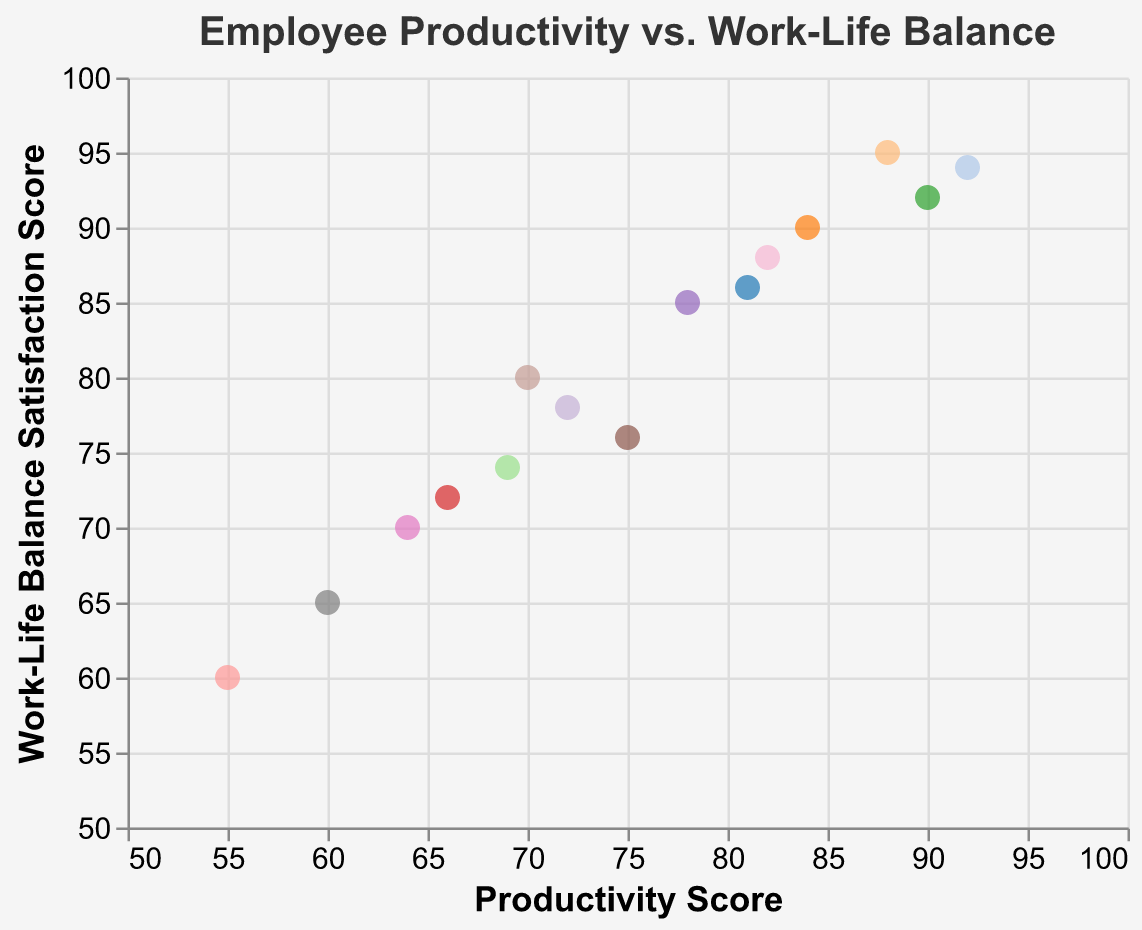What's the title of the scatter plot? The title is usually found at the top of the chart and indicates what the chart is about. By inspecting the plot, we can see the title text clearly.
Answer: Employee Productivity vs. Work-Life Balance What is the range of the Productivity Score on the x-axis? To determine the range of the x-axis, we inspect the minimum and maximum values shown on the axis. The scores range from 50 to 100.
Answer: 50 to 100 Which employee has both the highest Productivity Score and Work-Life Balance Satisfaction Score? To find this information, look for the highest points on both the x-axis and y-axis and check the tooltip details or the data plot.
Answer: Daniel Anderson How many employees have a Productivity Score greater than 80? Count the number of points on the plot that are to the right of the 80 mark on the x-axis. There are 6 such points.
Answer: 6 What are the Productivity Score and Work-Life Balance Satisfaction Score for Michael Brown? Identify the point labeled with Michael Brown and read the values of the Productivity Score and Work-Life Balance Satisfaction Score from the plot or tooltip.
Answer: 75 and 76 Which employee has the lowest Work-Life Balance Satisfaction Score, and what is their Productivity Score? Find the lowest point along the y-axis and check the corresponding tooltip or data for the Productivity Score. The lowest score on the y-axis belongs to James Miller.
Answer: Productivity Score: 55, Work-Life Balance Satisfaction Score: 60 Is there a noticeable correlation between Productivity Score and Work-Life Balance Satisfaction Score? Look for a trend in the scatter plot. Points that trend in a line suggest correlation. The visible relationship shows that as Productivity Score increases, Work-Life Balance Satisfaction Score tends to increase as well.
Answer: Yes, positive correlation How many employees have both scores (Productivity and Work-Life Balance) above 90? Locate the points in the upper-right quadrant of the plot where both x and y values are above 90 and count them. There are 2 such points.
Answer: 2 What is the average Work-Life Balance Satisfaction Score for employees who have a Productivity Score below 70? Identify the points on the plot left of the 70 mark on the x-axis, sum their y values, and divide by the number of these points. Those points correspond to James Miller, Sophia Thomas, and Richard Lee with scores 60, 65, and 70, so the average is (60+65+70)/3 = 65.
Answer: 65 